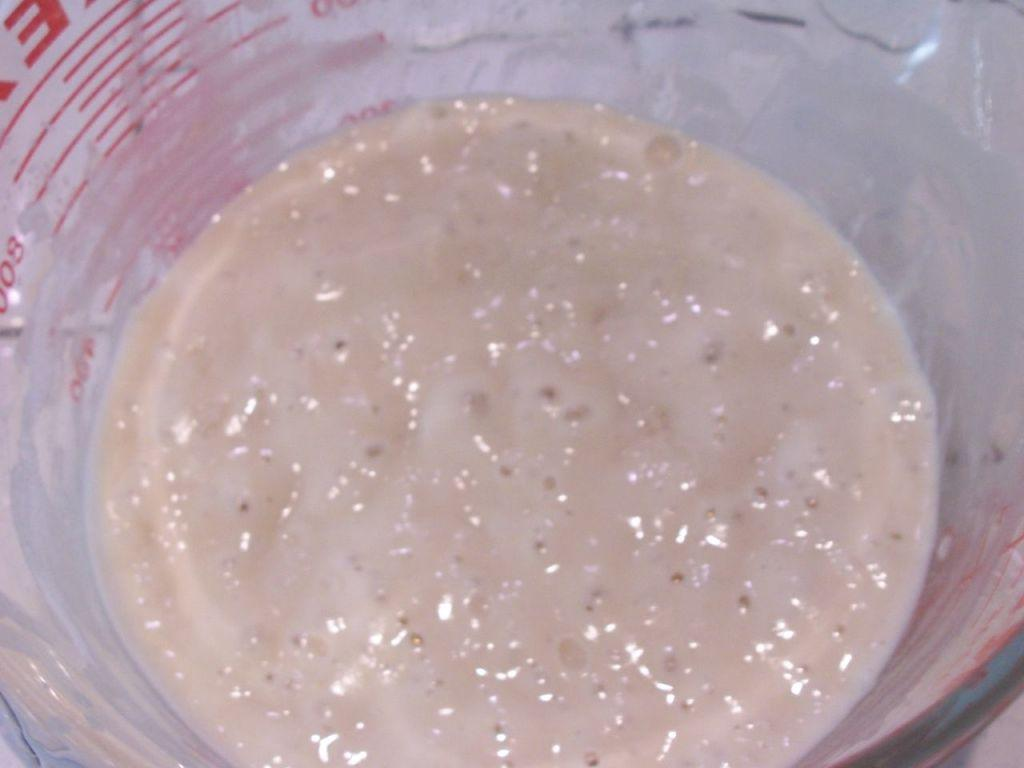What is the main subject in the image? There is a food item in a bowl in the image. What type of honey is being used to transport the food item in the image? There is no honey or transportation of the food item present in the image. What type of string is being used to hold the food item in the image? There is no string present in the image, and the food item is in a bowl. 